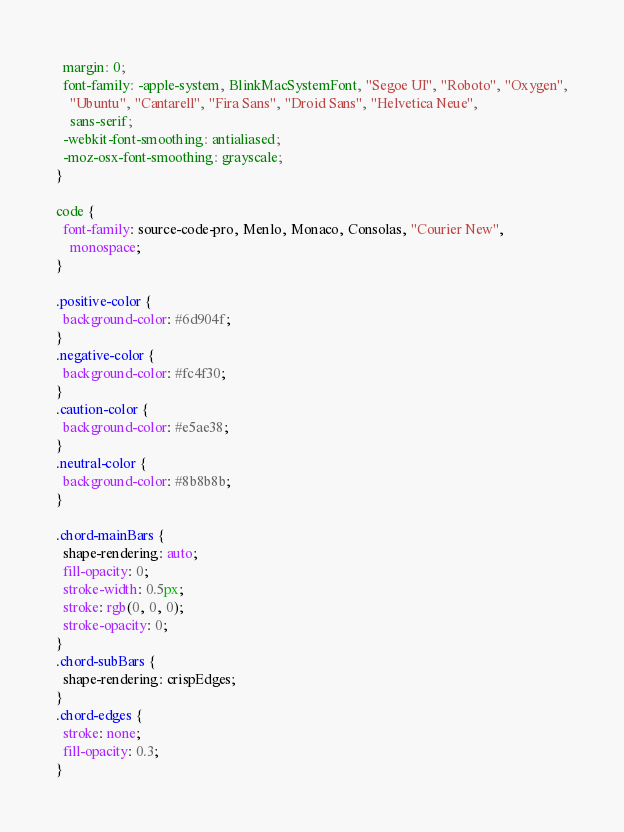Convert code to text. <code><loc_0><loc_0><loc_500><loc_500><_CSS_>  margin: 0;
  font-family: -apple-system, BlinkMacSystemFont, "Segoe UI", "Roboto", "Oxygen",
    "Ubuntu", "Cantarell", "Fira Sans", "Droid Sans", "Helvetica Neue",
    sans-serif;
  -webkit-font-smoothing: antialiased;
  -moz-osx-font-smoothing: grayscale;
}

code {
  font-family: source-code-pro, Menlo, Monaco, Consolas, "Courier New",
    monospace;
}

.positive-color {
  background-color: #6d904f;
}
.negative-color {
  background-color: #fc4f30;
}
.caution-color {
  background-color: #e5ae38;
}
.neutral-color {
  background-color: #8b8b8b;
}

.chord-mainBars {
  shape-rendering: auto;
  fill-opacity: 0;
  stroke-width: 0.5px;
  stroke: rgb(0, 0, 0);
  stroke-opacity: 0;
}
.chord-subBars {
  shape-rendering: crispEdges;
}
.chord-edges {
  stroke: none;
  fill-opacity: 0.3;
}
</code> 